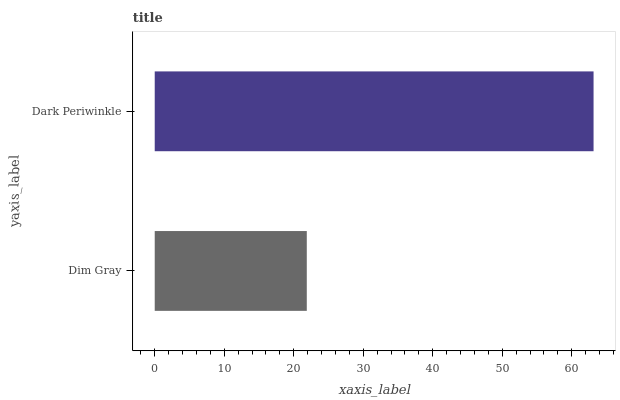Is Dim Gray the minimum?
Answer yes or no. Yes. Is Dark Periwinkle the maximum?
Answer yes or no. Yes. Is Dark Periwinkle the minimum?
Answer yes or no. No. Is Dark Periwinkle greater than Dim Gray?
Answer yes or no. Yes. Is Dim Gray less than Dark Periwinkle?
Answer yes or no. Yes. Is Dim Gray greater than Dark Periwinkle?
Answer yes or no. No. Is Dark Periwinkle less than Dim Gray?
Answer yes or no. No. Is Dark Periwinkle the high median?
Answer yes or no. Yes. Is Dim Gray the low median?
Answer yes or no. Yes. Is Dim Gray the high median?
Answer yes or no. No. Is Dark Periwinkle the low median?
Answer yes or no. No. 